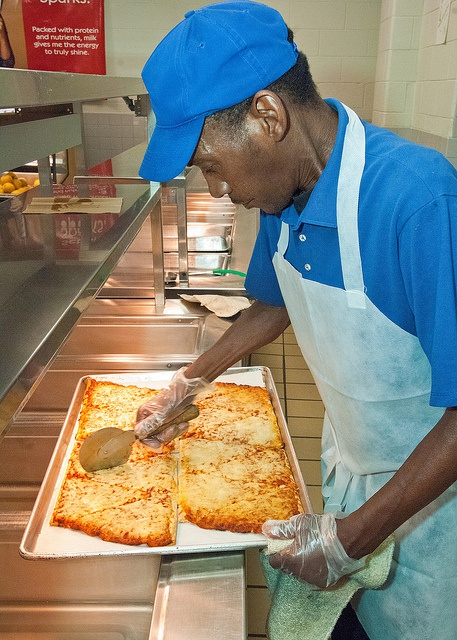Describe the objects in this image and their specific colors. I can see people in darkgray, blue, gray, and teal tones, pizza in darkgray, orange, and tan tones, pizza in darkgray, khaki, orange, and gold tones, pizza in darkgray, tan, orange, and red tones, and pizza in darkgray, khaki, gold, and orange tones in this image. 